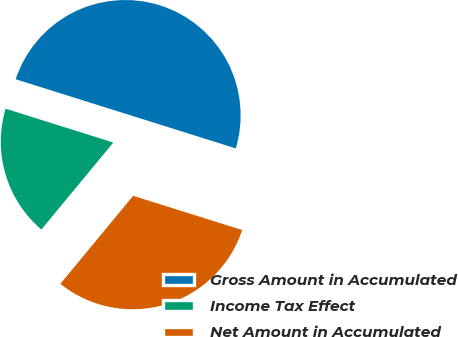Convert chart to OTSL. <chart><loc_0><loc_0><loc_500><loc_500><pie_chart><fcel>Gross Amount in Accumulated<fcel>Income Tax Effect<fcel>Net Amount in Accumulated<nl><fcel>50.0%<fcel>18.85%<fcel>31.15%<nl></chart> 